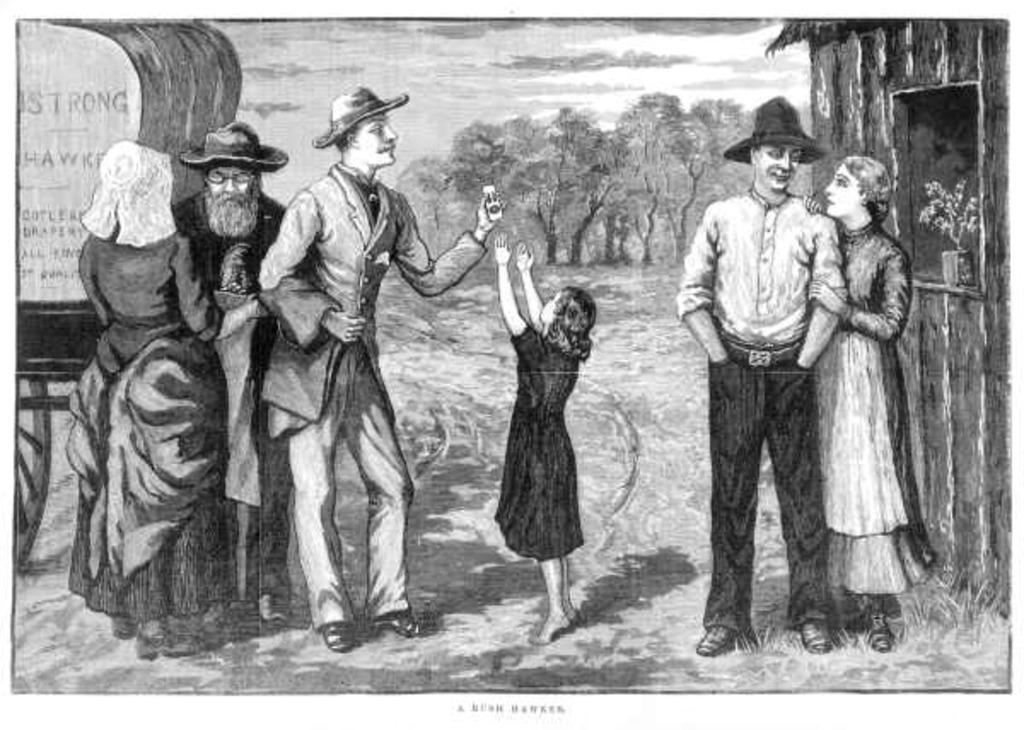What are the persons in the sketch doing? The persons in the sketch are standing on the ground. What objects can be seen in the sketch besides the persons? There are flower pots, trees, and a cart in the sketch. What is visible in the background of the sketch? The sky is visible in the sketch, and clouds are present in the sky. What type of education can be seen being provided in the sketch? There is no indication of education being provided in the sketch; it primarily features persons standing on the ground, flower pots, trees, a cart, the sky, and clouds. What is the purpose of the soap in the sketch? There is no soap present in the sketch; it contains persons standing on the ground, flower pots, trees, a cart, the sky, and clouds. 